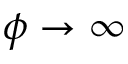Convert formula to latex. <formula><loc_0><loc_0><loc_500><loc_500>\phi \rightarrow \infty</formula> 